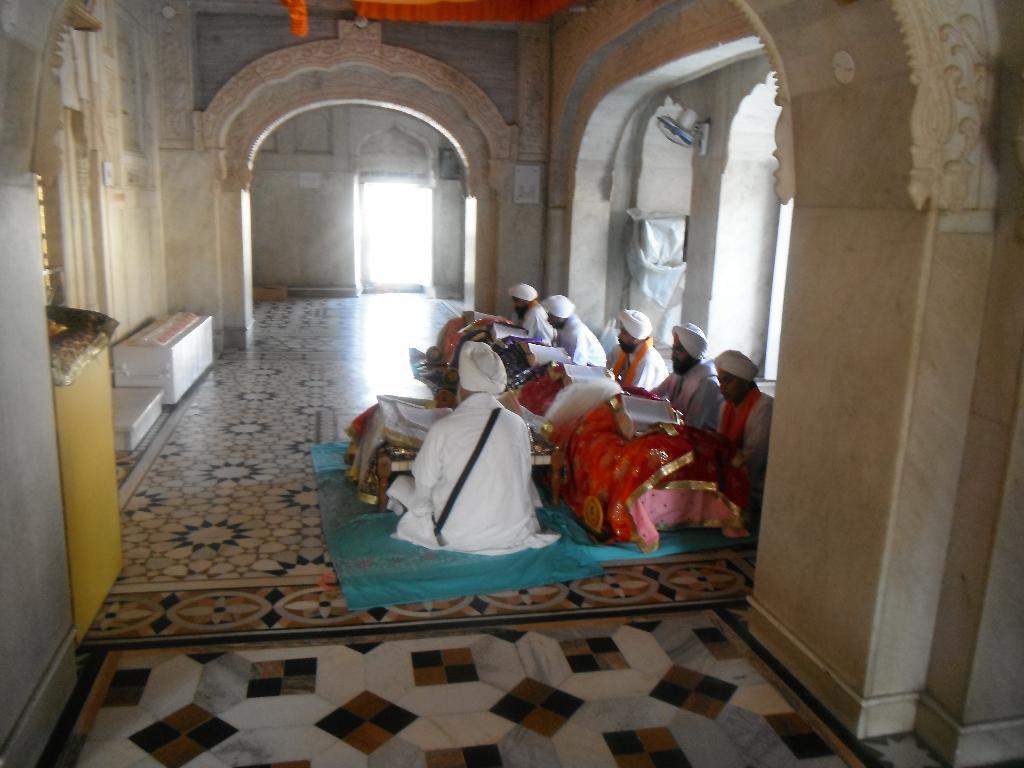Describe this image in one or two sentences. In this image there are people sitting on a floor, beside them there are walls. 